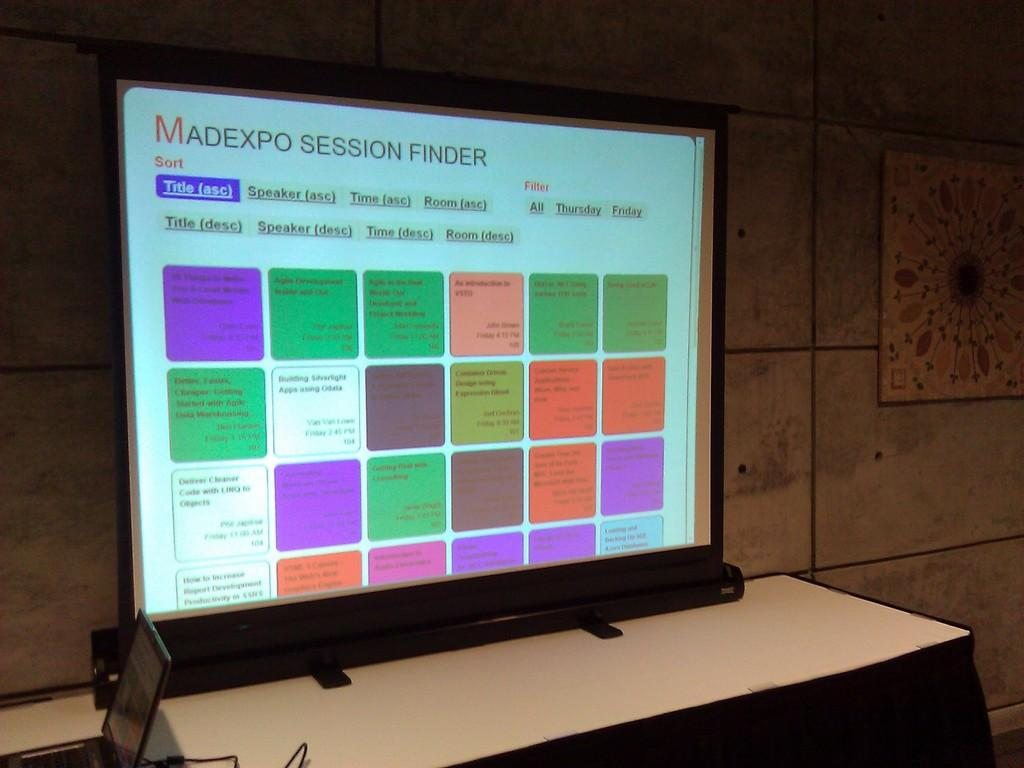<image>
Write a terse but informative summary of the picture. A large display monitor shows us a Madexp Session finder, a guide to the events that will be happening. 